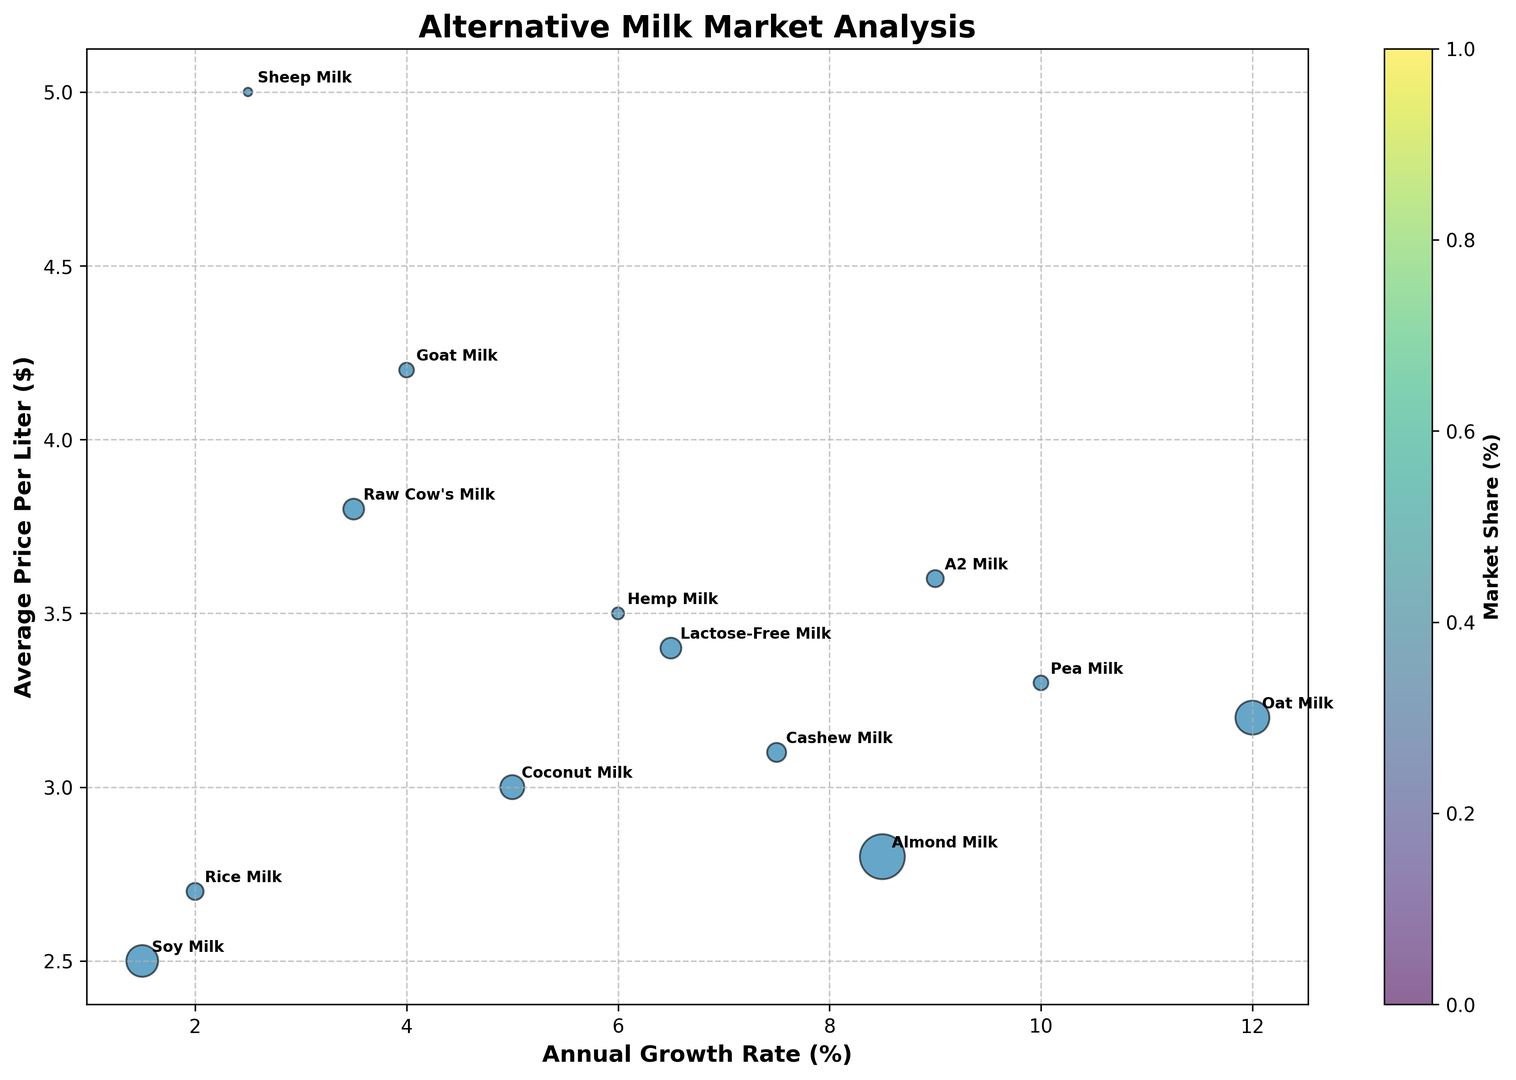What's the most expensive milk option? Look at the y-axis labeled "Average Price Per Liter ($)," and find the highest value. "Sheep Milk" sits at $5.00, making it the most expensive milk option.
Answer: Sheep Milk Which milk type has the highest annual growth rate? Look at the x-axis labeled "Annual Growth Rate (%)" and find the highest value. The bubble "Oat Milk" is positioned the furthest to the right with a growth rate of 12.0%.
Answer: Oat Milk What is the annual growth rate and price of raw cow’s milk? Locate "Raw Cow's Milk" and find its position along the x-axis and y-axis, which represent the annual growth rate and average price per liter, respectively. The coordinates are 3.5% (growth rate) and $3.80 (price).
Answer: 3.5%, $3.80 Compare almond milk and soy milk: Which one has a higher market share, and by how much? Look at the size of the bubbles for "Almond Milk" and "Soy Milk." Almond Milk (size 28) has a larger bubble than Soy Milk (size 14). The difference is 28 - 14 = 14.
Answer: Almond Milk by 14 Rank the animal-based milk types by their market share. Identify the bubbles for Raw Cow’s Milk, Goat Milk, and Sheep Milk. Their market shares are 6%, 3%, and 1%, respectively. Sorting these values: Raw Cow’s Milk > Goat Milk > Sheep Milk.
Answer: Raw Cow’s Milk, Goat Milk, Sheep Milk Which milk types have a higher growth rate than raw cow’s milk? Identify Raw Cow's Milk's growth rate, which is 3.5%, and check other bubbles to see which ones have growth rates above 3.5%. Almond Milk (8.5%), Oat Milk (12.0%), Coconut Milk (5.0%), Cashew Milk (7.5%), Hemp Milk (6.0%), Pea Milk (10.0%), A2 Milk (9.0%), and Lactose-Free Milk (6.5%) have higher growth rates.
Answer: Almond Milk, Oat Milk, Coconut Milk, Cashew Milk, Hemp Milk, Pea Milk, A2 Milk, Lactose-Free Milk Which milk type has both a high growth rate and a low average price per liter? Find a bubble that is far right (high growth rate) but comparatively lower on the chart (low price). Pea Milk has a high growth rate (10.0%) and a relatively moderate price ($3.30).
Answer: Pea Milk Which plant-based milk has the smallest market share? Locate the smallest bubble among plant-based milk types. "Hemp Milk" has the smallest share with only 2%.
Answer: Hemp Milk Does almond milk have a higher or lower price per liter than cashew milk? Compare the y-axis positions of "Almond Milk" and "Cashew Milk." Almond Milk is at $2.80, while Cashew Milk is at $3.10. Therefore, Almond Milk is lower.
Answer: Lower What is the average price per liter for milk types with a market share of at least 6%? Identify the milk types Raw Cow's Milk, Almond Milk, Soy Milk, Oat Milk, and Coconut Milk in this category. Their prices are $3.80, $2.80, $2.50, $3.20, and $3.00 respectively. Average = (3.80 + 2.80 + 2.50 + 3.20 + 3.00)/5 = $3.06
Answer: $3.06 